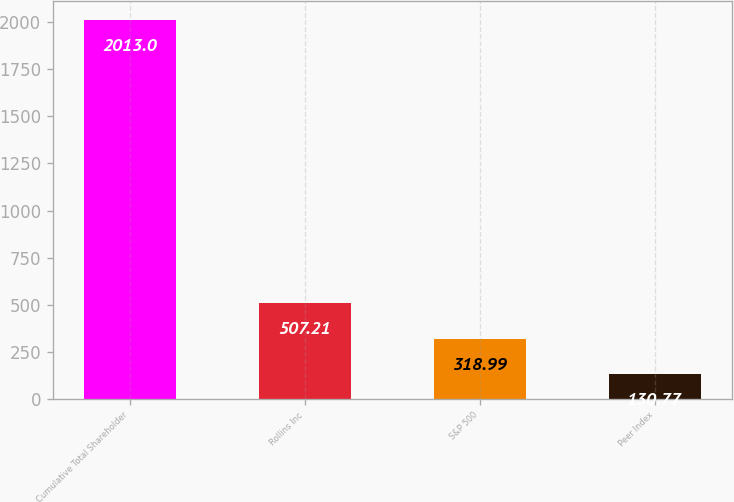Convert chart. <chart><loc_0><loc_0><loc_500><loc_500><bar_chart><fcel>Cumulative Total Shareholder<fcel>Rollins Inc<fcel>S&P 500<fcel>Peer Index<nl><fcel>2013<fcel>507.21<fcel>318.99<fcel>130.77<nl></chart> 